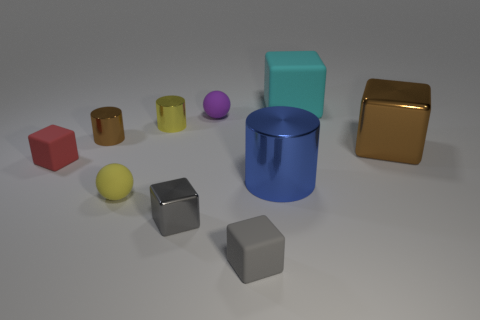What time of day does the lighting in the picture suggest? The lighting in the image seems to be artificial, likely coming from a neutral light source, as opposed to natural daylight. This does not clearly indicate the time of day but suggests that the objects are placed inside, under controlled lighting conditions, possibly for display or examination. Can you tell anything about the material of these objects? The objects appear to have different materials. The cylinders and one of the cubes have reflective surfaces, resembling metals, while the other shapes have a more matte finish, which suggests they could be made of rubber or plastic. 